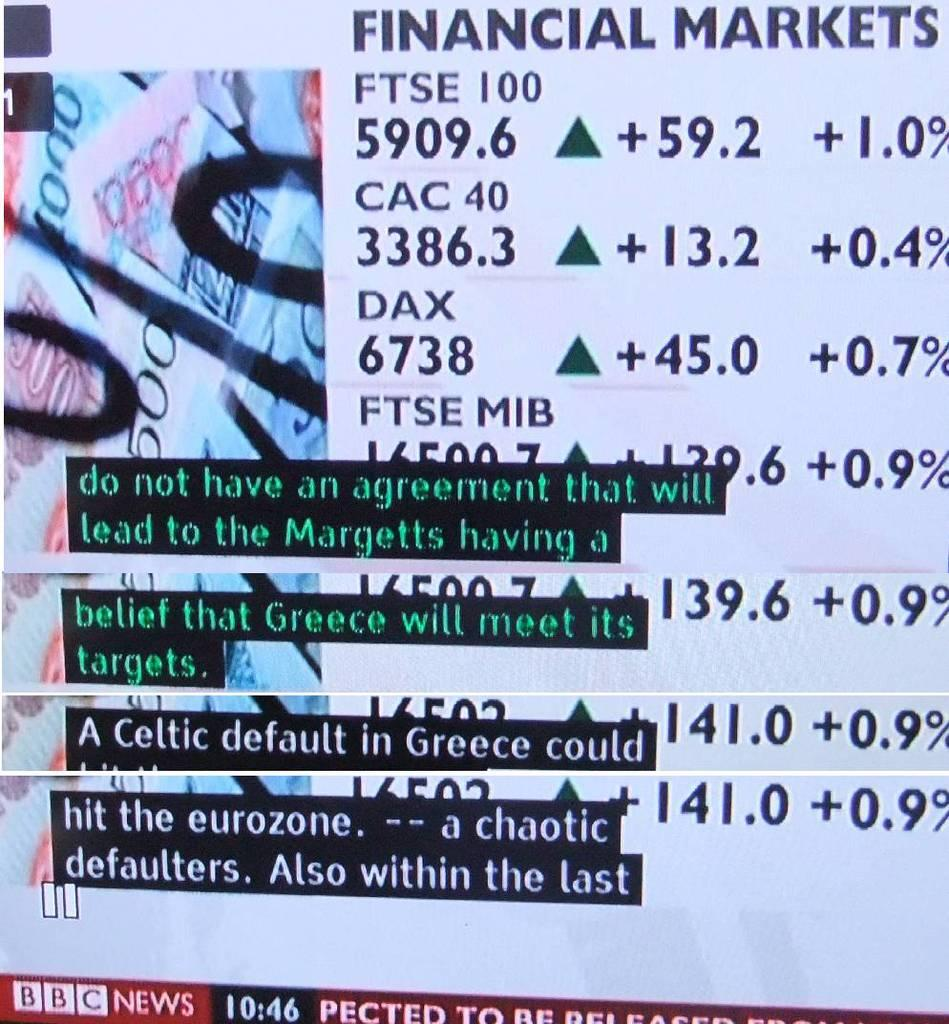What is the main object in the center of the image? There is a screen in the center of the image. What can be seen on the screen? Text and numbers are visible on the screen. What flavor of news is being reported on the screen? There is no news or flavor mentioned in the image; it only shows text and numbers on a screen. 